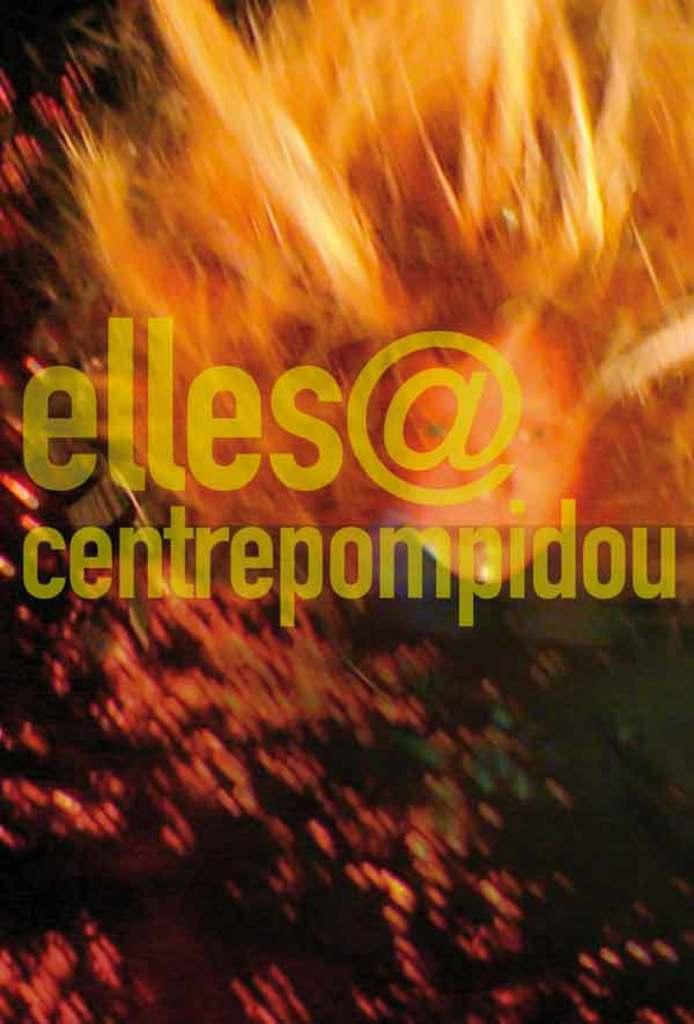What is the nature of the image? The image is edited. What is one of the prominent elements in the image? There is fire in the image. Can you describe any text present in the image? Yes, there is some text in the middle of the image. How many apples can be seen in the image? There are no apples present in the image. What type of thumb is visible in the image? There is no thumb visible in the image. How many rings are featured on the fire in the image? There are no rings present in the image. 